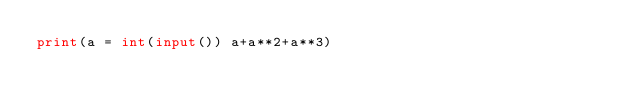Convert code to text. <code><loc_0><loc_0><loc_500><loc_500><_Python_>print(a = int(input()) a+a**2+a**3)</code> 